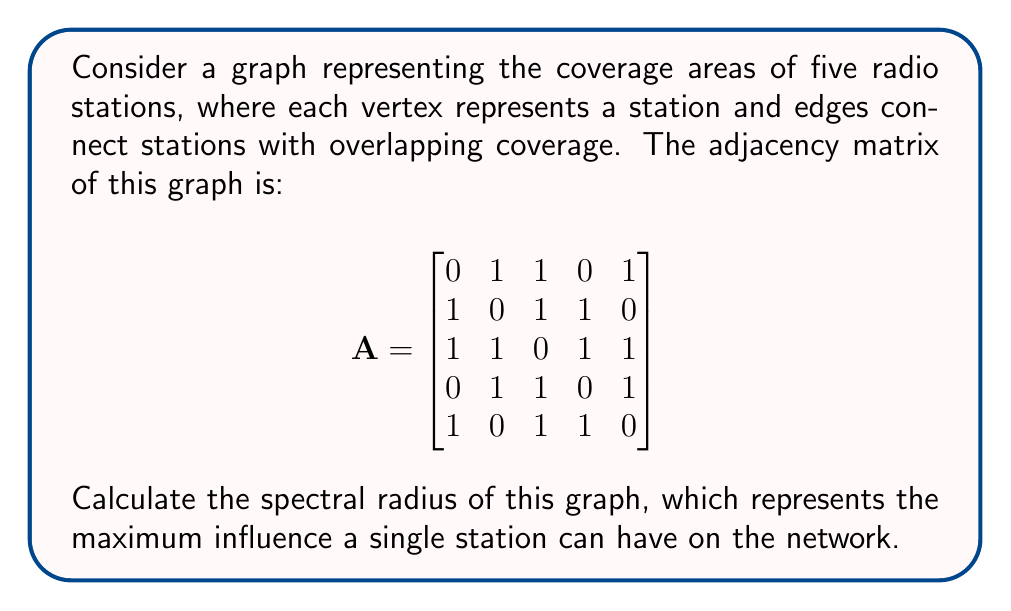Teach me how to tackle this problem. To find the spectral radius of the graph, we need to follow these steps:

1. The spectral radius is the largest absolute value of the eigenvalues of the adjacency matrix A.

2. To find the eigenvalues, we need to solve the characteristic equation:
   $\det(A - \lambda I) = 0$, where I is the 5x5 identity matrix.

3. Expanding this determinant gives us the characteristic polynomial:
   $\lambda^5 - 8\lambda^3 - 8\lambda^2 + 16\lambda = 0$

4. Factoring this polynomial:
   $\lambda(\lambda^4 - 8\lambda^2 - 8\lambda + 16) = 0$

5. Solving this equation, we get the eigenvalues:
   $\lambda_1 = 0$
   $\lambda_2 \approx -2.1861$
   $\lambda_3 \approx -1.2720$
   $\lambda_4 \approx 1.6506$
   $\lambda_5 \approx 2.8075$

6. The spectral radius is the largest absolute value among these eigenvalues, which is approximately 2.8075.

This value represents the maximum influence a single station can have on the network, indicating the potential for signal propagation and interference in the radio station coverage system.
Answer: $2.8075$ (approximate) 